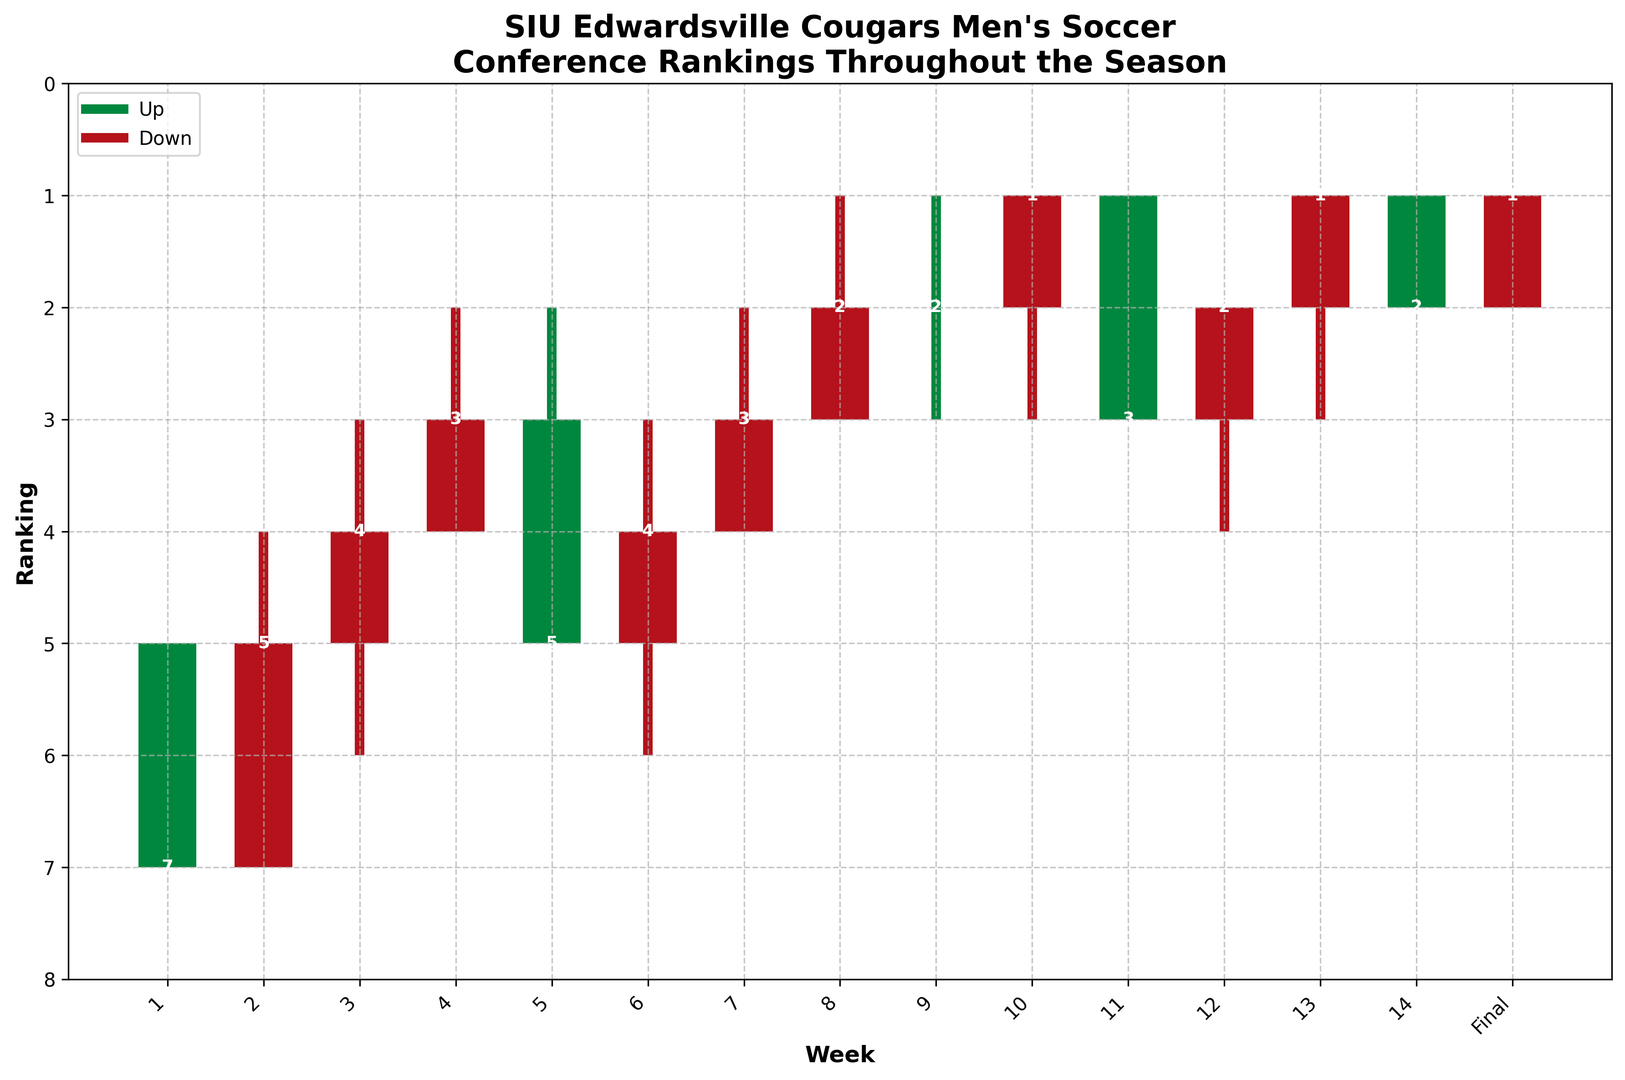What week did the SIU Edwardsville Cougars men's soccer team achieve their highest ranking? From the plot, the highest ranking achieved by the team during the season is indicated by the lowest position (closer to 1). Throughout the season, the highest ranking of 1 is achieved first in Week 8.
Answer: Week 8 What is the difference in conference ranking from the beginning to the end of the season? Initially, in Week 1, the team's ranking was 5. By the final week, their ranking improved to 1. The difference in ranking from the start to the end is 5 - 1.
Answer: 4 In which week(s) did the Cougars experience an improvement in their ranking? Observe the weekly 'Close' values and check the weeks where the 'Close' value is lower than the previous week's 'Close' value. Improvements are seen in weeks 3, 4, 8, and 9.
Answer: Weeks 3, 4, 8, 9 Over the course of the season, how many weeks did the Cougars' ranking end higher than it opened (represented by green bars)? The green bars in the candlestick chart represent weeks where the team's ranking ended higher than it started. Counting the green bars, we see them in weeks 3, 4, 8, 9, 10, 12, and 13.
Answer: 7 During which week did the Cougars have the largest week-over-week change in their lowest ranking? The largest change in the lowest ranking (represented by 'Low') occurs when comparing consecutive weeks' low positions. From Week 7 to Week 8, the low goes from 4 to 3, a change of 1. This is seen again from Week 8 to Week 9, with a change of 2 (3 to 1), which is the largest observed.
Answer: Week 8 to Week 9 Did the team finish the season with a ranking better than or worse than how they started? The initial ranking (Week 1 'Close') is 7. The final ranking ('Final' Close) is 1. Since 1 is better than 7 (higher rankings are better), they finished better.
Answer: Better What is the average of the highest rankings achieved from Week 1 to Week 14? The 'High' values across the weeks indicate the highest achieved rankings. Sum up the 'High' values and divide by the number of weeks: (5 + 4 + 3 + 2 + 2 + 3 + 2 + 1 + 1 + 1 + 1 + 2 + 1 + 1) / 14 = 2.142857.
Answer: 2.14 What trend is observed in the Cougars' weekly ranking performance over the latter half of the season (from Week 7 to the Final)? Observing the 'Close' values from Week 7 to the Final, the rankings consistently improve, moving from 3 to 2 to 1, with slight ups and downs, showing an overall improving trend.
Answer: Improving Which week had the Cougars’ ranking close the farthest below the opening rank? Look for the largest negative difference between 'Open' and 'Close' values. Week 1 has the biggest decrease: 5 (Open) to 7 (Close), a difference of 2.
Answer: Week 1 